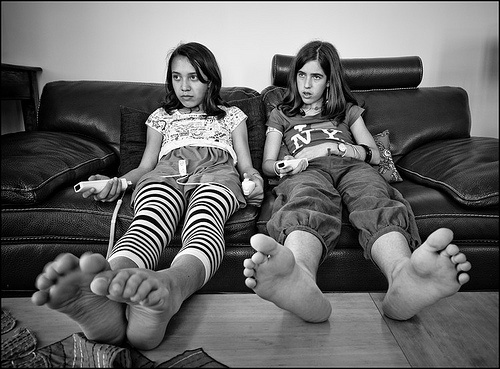Describe the objects in this image and their specific colors. I can see people in black, gray, darkgray, and lightgray tones, people in black, gray, darkgray, and lightgray tones, couch in black, gray, darkgray, and lightgray tones, couch in black, gray, darkgray, and gainsboro tones, and remote in black, lightgray, darkgray, and gray tones in this image. 